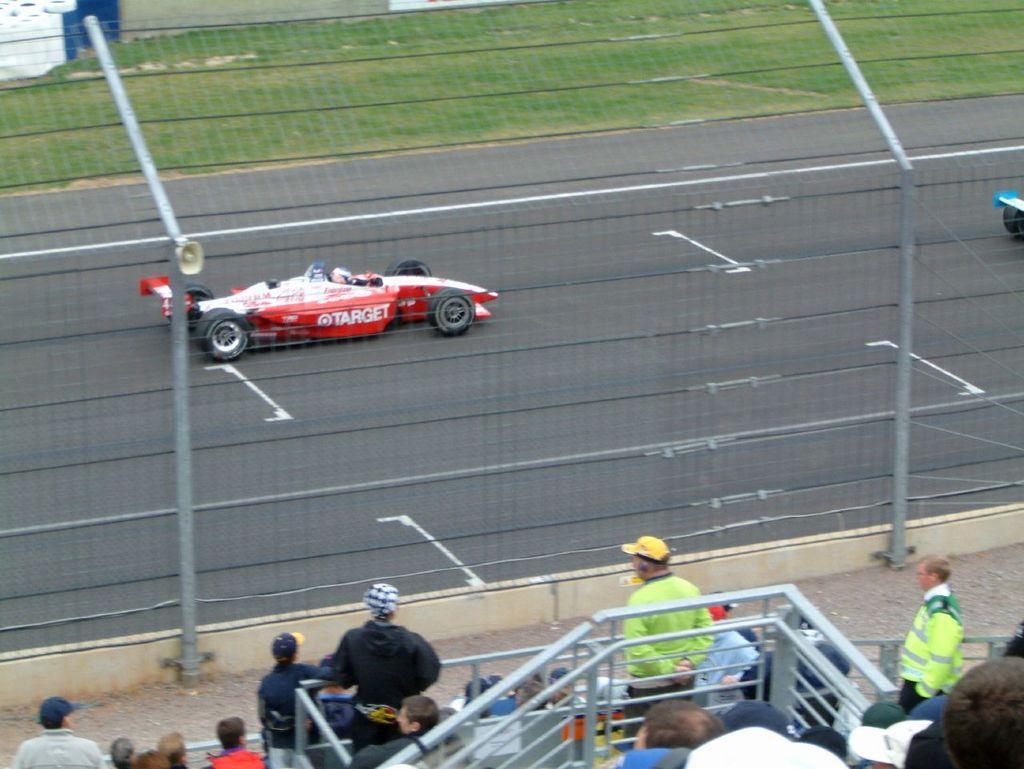Could you give a brief overview of what you see in this image? This picture is clicked outside. In the foreground we can see the group of people and the metal rods. In the center there is a red color Go-kart seems to be running on the road and we can see the metal rods. In the background there is a green grass and some other objects. 